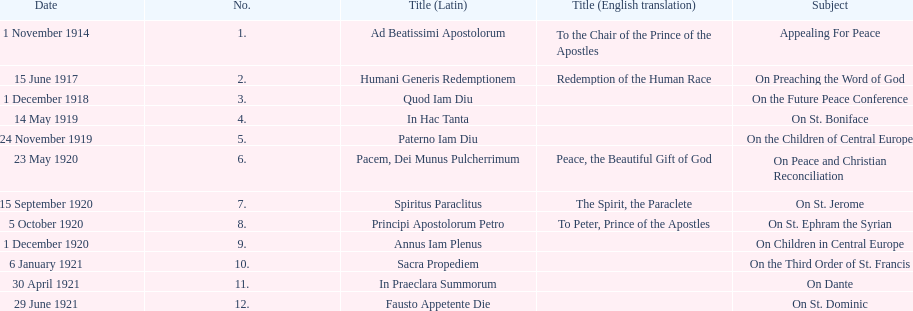What are the number of titles with a date of november? 2. 